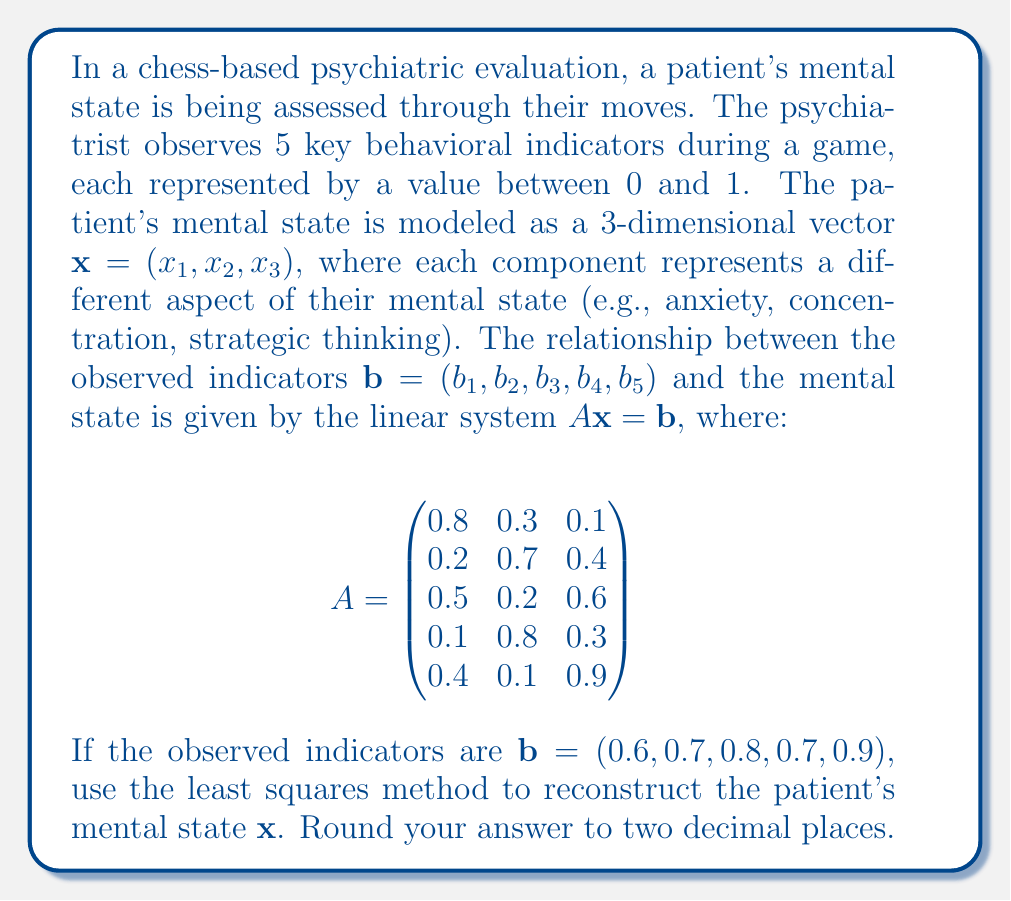Teach me how to tackle this problem. To solve this inverse problem using the least squares method, we need to follow these steps:

1) The least squares solution is given by the formula:
   $\mathbf{x} = (A^TA)^{-1}A^T\mathbf{b}$

2) First, let's calculate $A^T$:
   $$A^T = \begin{pmatrix}
   0.8 & 0.2 & 0.5 & 0.1 & 0.4 \\
   0.3 & 0.7 & 0.2 & 0.8 & 0.1 \\
   0.1 & 0.4 & 0.6 & 0.3 & 0.9
   \end{pmatrix}$$

3) Now, let's calculate $A^TA$:
   $$A^TA = \begin{pmatrix}
   0.94 & 0.67 & 0.59 \\
   0.67 & 1.27 & 0.58 \\
   0.59 & 0.58 & 1.22
   \end{pmatrix}$$

4) We need to find $(A^TA)^{-1}$. Using a calculator or computer algebra system:
   $$(A^TA)^{-1} = \begin{pmatrix}
   1.5625 & -0.6914 & -0.4883 \\
   -0.6914 & 1.2305 & -0.1992 \\
   -0.4883 & -0.1992 & 1.1133
   \end{pmatrix}$$

5) Now, let's calculate $A^T\mathbf{b}$:
   $$A^T\mathbf{b} = \begin{pmatrix}
   1.54 \\
   1.55 \\
   1.89
   \end{pmatrix}$$

6) Finally, we can calculate $\mathbf{x}$:
   $$\mathbf{x} = (A^TA)^{-1}A^T\mathbf{b} = \begin{pmatrix}
   0.6646 \\
   0.8042 \\
   1.0312
   \end{pmatrix}$$

7) Rounding to two decimal places:
   $$\mathbf{x} \approx \begin{pmatrix}
   0.66 \\
   0.80 \\
   1.03
   \end{pmatrix}$$

This result represents the reconstructed mental state of the patient based on the observed behavioral indicators during the chess game.
Answer: $(0.66, 0.80, 1.03)$ 